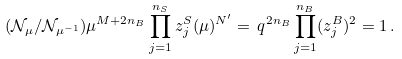<formula> <loc_0><loc_0><loc_500><loc_500>( \mathcal { N } _ { \mu } / \mathcal { N } _ { \mu ^ { - 1 } } ) \mu ^ { M + 2 n _ { B } } \prod _ { j = 1 } ^ { n _ { S } } z _ { j } ^ { S } ( \mu ) ^ { N ^ { \prime } } = \, q ^ { 2 n _ { B } } \prod _ { j = 1 } ^ { n _ { B } } ( z _ { j } ^ { B } ) ^ { 2 } = 1 \, .</formula> 